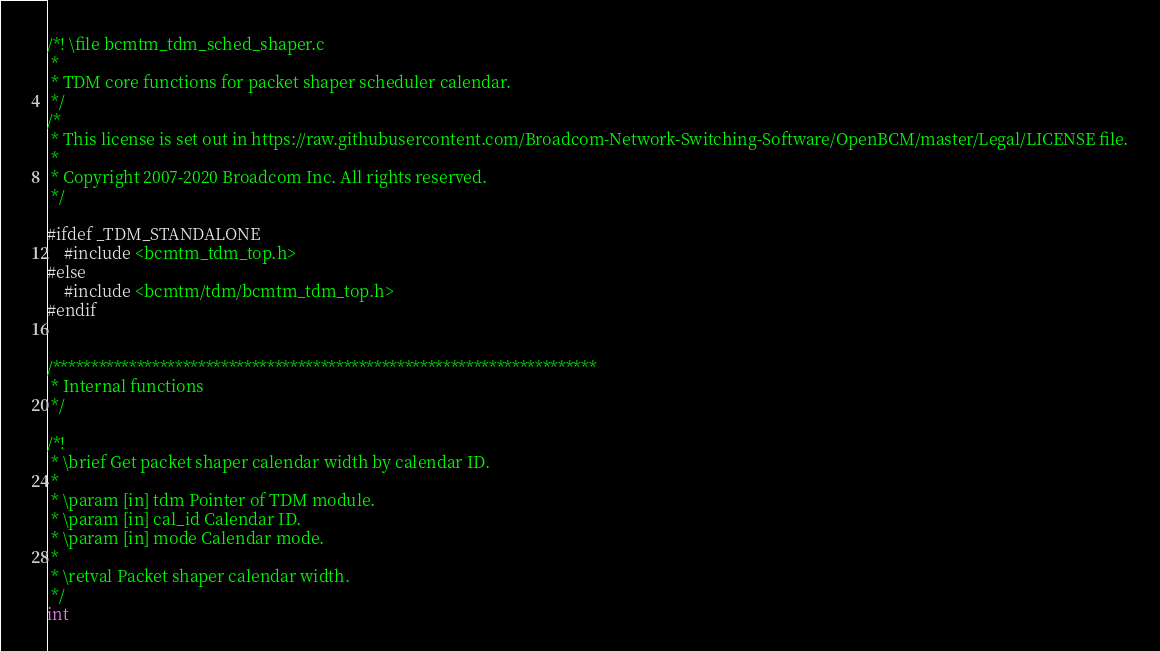<code> <loc_0><loc_0><loc_500><loc_500><_C_>/*! \file bcmtm_tdm_sched_shaper.c
 *
 * TDM core functions for packet shaper scheduler calendar.
 */
/*
 * This license is set out in https://raw.githubusercontent.com/Broadcom-Network-Switching-Software/OpenBCM/master/Legal/LICENSE file.
 * 
 * Copyright 2007-2020 Broadcom Inc. All rights reserved.
 */

#ifdef _TDM_STANDALONE
    #include <bcmtm_tdm_top.h>
#else
    #include <bcmtm/tdm/bcmtm_tdm_top.h>
#endif


/***********************************************************************
 * Internal functions
 */

/*!
 * \brief Get packet shaper calendar width by calendar ID.
 *
 * \param [in] tdm Pointer of TDM module.
 * \param [in] cal_id Calendar ID.
 * \param [in] mode Calendar mode.
 *
 * \retval Packet shaper calendar width.
 */
int</code> 